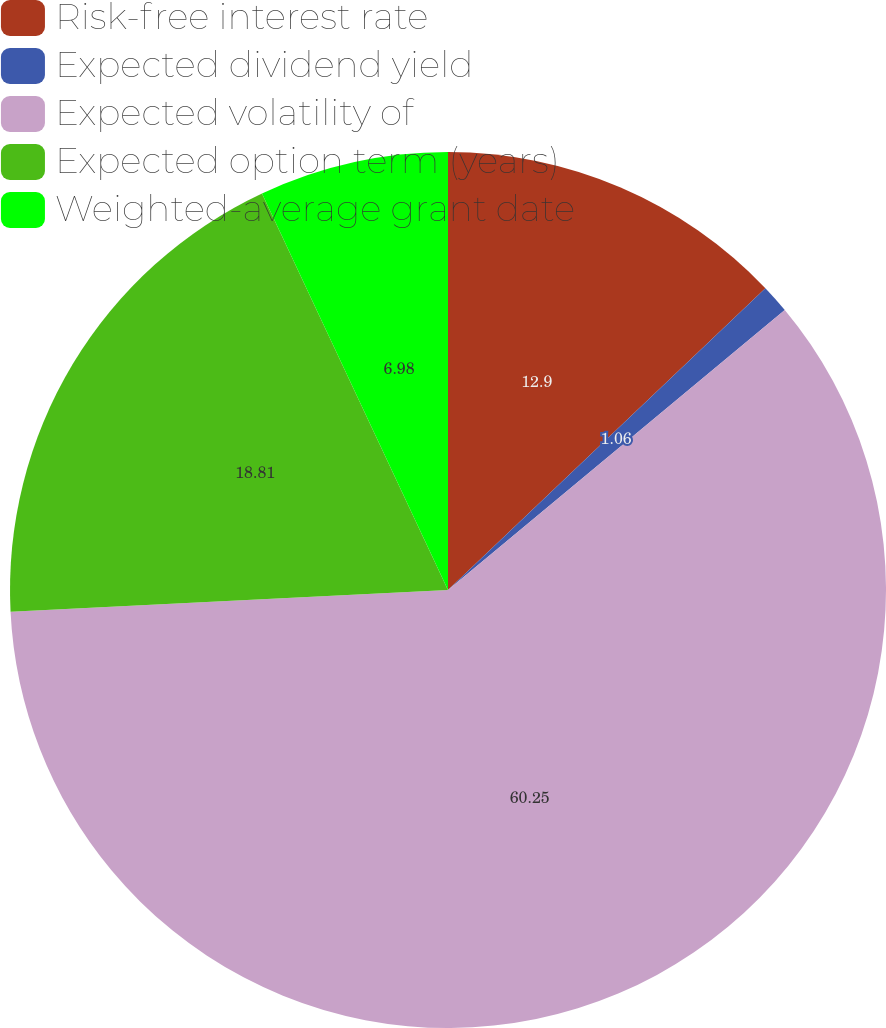Convert chart. <chart><loc_0><loc_0><loc_500><loc_500><pie_chart><fcel>Risk-free interest rate<fcel>Expected dividend yield<fcel>Expected volatility of<fcel>Expected option term (years)<fcel>Weighted-average grant date<nl><fcel>12.9%<fcel>1.06%<fcel>60.25%<fcel>18.81%<fcel>6.98%<nl></chart> 